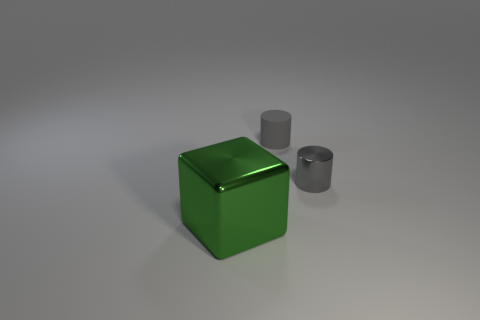Add 2 brown metallic cylinders. How many objects exist? 5 Subtract all cubes. How many objects are left? 2 Subtract 0 gray balls. How many objects are left? 3 Subtract all cylinders. Subtract all small rubber objects. How many objects are left? 0 Add 3 big green blocks. How many big green blocks are left? 4 Add 1 tiny gray objects. How many tiny gray objects exist? 3 